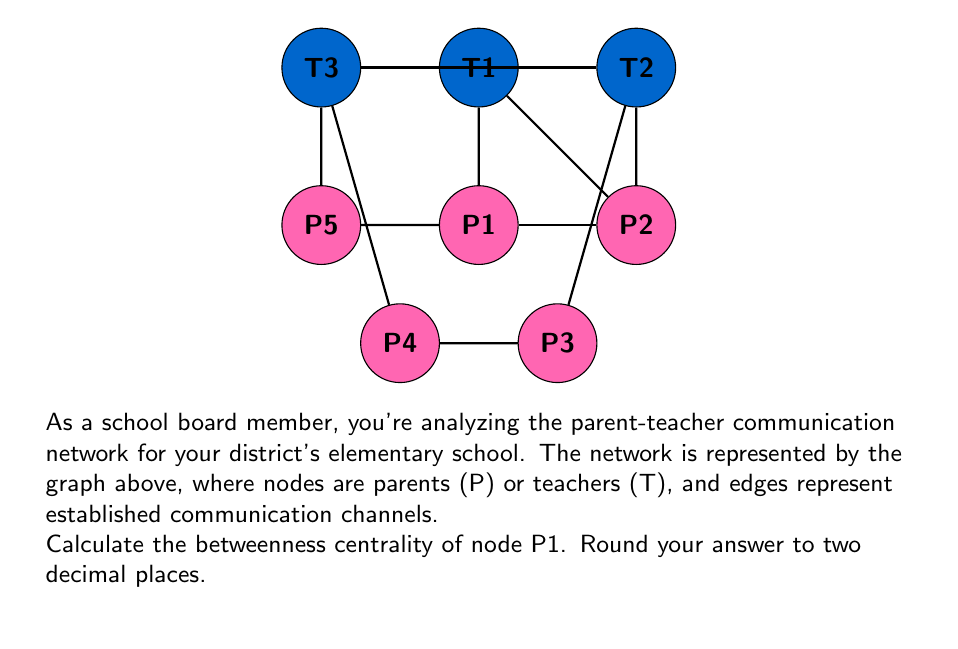Provide a solution to this math problem. To calculate the betweenness centrality of node P1, we need to follow these steps:

1) Betweenness centrality is defined as:

   $$C_B(v) = \sum_{s \neq v \neq t} \frac{\sigma_{st}(v)}{\sigma_{st}}$$

   where $\sigma_{st}$ is the total number of shortest paths from node s to node t, and $\sigma_{st}(v)$ is the number of those paths that pass through v.

2) We need to consider all pairs of nodes (except those involving P1) and count how many shortest paths between them pass through P1.

3) Let's examine each pair:

   - T1-T2, T1-T3, T2-T3: P1 is not on any shortest path
   - T1-P2, T2-P2: P1 is not on the shortest path
   - T3-P2: 1 out of 2 shortest paths goes through P1
   - T1-P3, T1-P4, T2-P3, T2-P4: All shortest paths go through P1
   - T3-P3, T3-P4: P1 is not on the shortest path
   - P2-P3, P2-P4: 1 out of 2 shortest paths goes through P1
   - P3-P4: P1 is not on the shortest path

4) Summing up the fractions:

   $$C_B(P1) = 0 + 0 + 0 + \frac{1}{2} + 1 + 1 + 1 + 1 + 0 + 0 + \frac{1}{2} + \frac{1}{2} + 0 = 5.5$$

5) To normalize this value, we divide by the number of possible node pairs excluding P1:

   $$\text{Number of pairs} = \frac{(n-1)(n-2)}{2} = \frac{(7)(6)}{2} = 21$$

6) Normalized betweenness centrality:

   $$C'_B(P1) = \frac{C_B(P1)}{21} = \frac{5.5}{21} \approx 0.2619$$

7) Rounding to two decimal places: 0.26
Answer: 0.26 